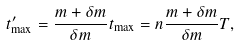<formula> <loc_0><loc_0><loc_500><loc_500>t ^ { \prime } _ { \max } = \frac { m + \delta m } { \delta m } t _ { \max } = n \frac { m + \delta m } { \delta m } T ,</formula> 